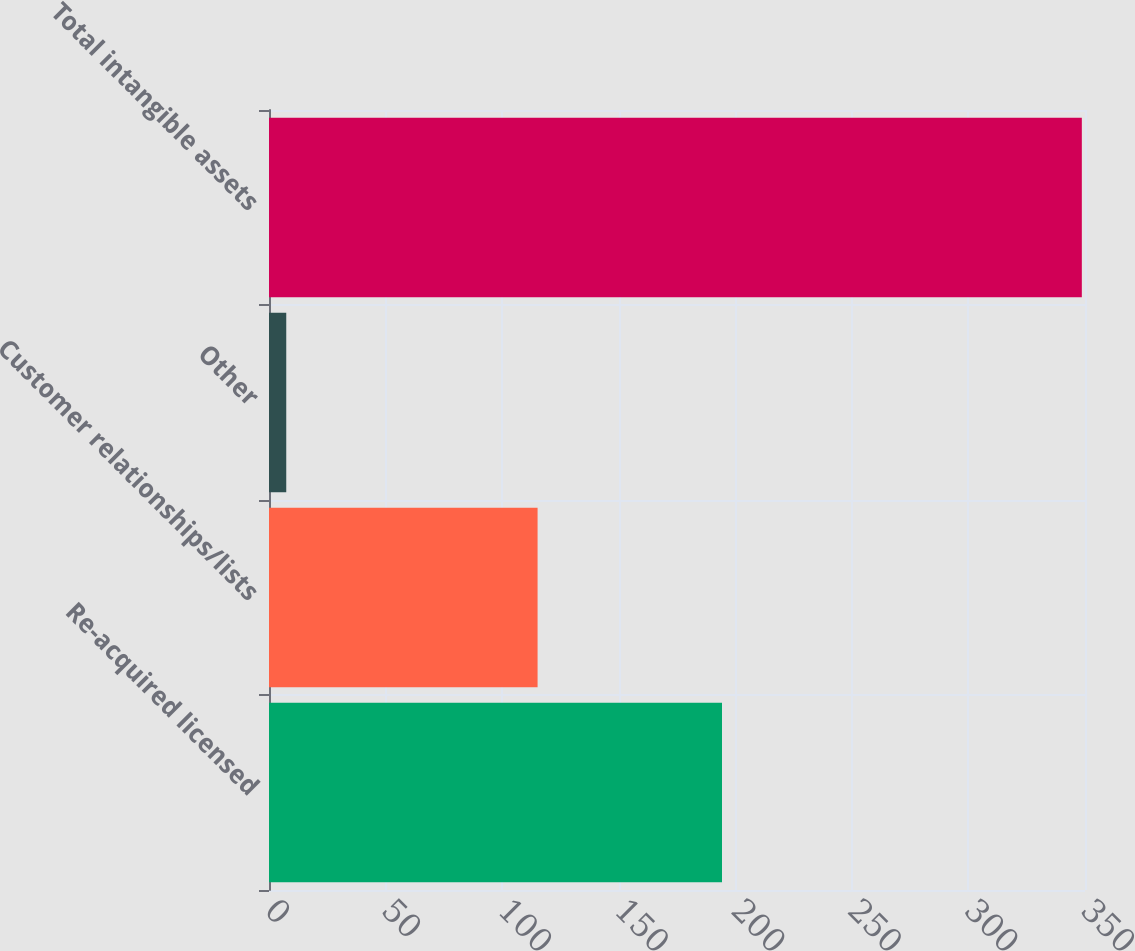Convert chart to OTSL. <chart><loc_0><loc_0><loc_500><loc_500><bar_chart><fcel>Re-acquired licensed<fcel>Customer relationships/lists<fcel>Other<fcel>Total intangible assets<nl><fcel>194.3<fcel>115.2<fcel>7.4<fcel>348.64<nl></chart> 